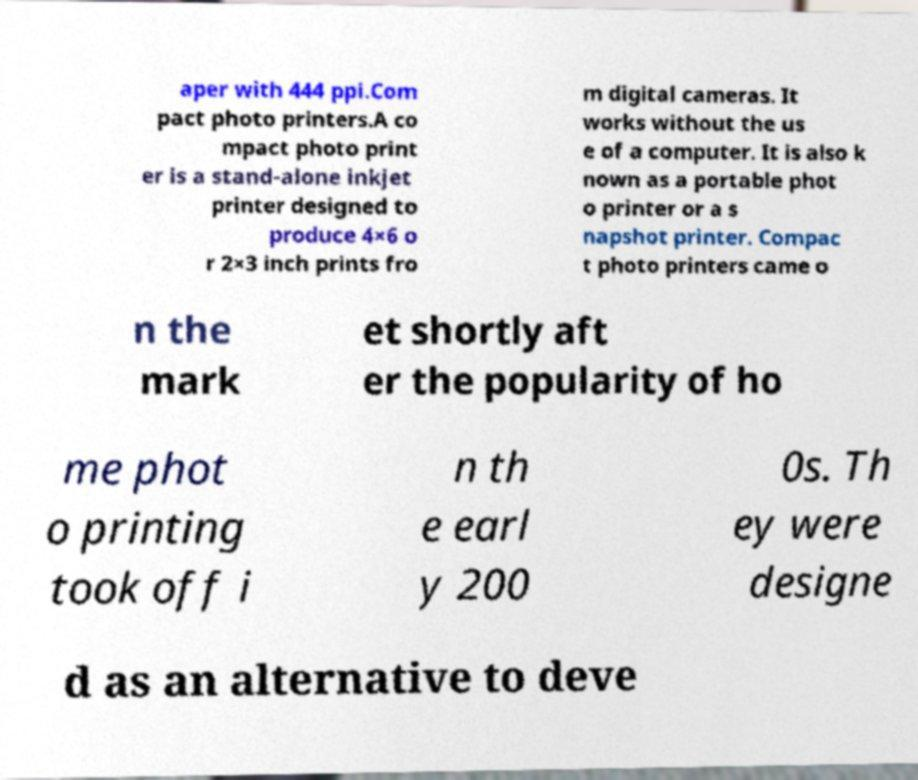Could you assist in decoding the text presented in this image and type it out clearly? aper with 444 ppi.Com pact photo printers.A co mpact photo print er is a stand-alone inkjet printer designed to produce 4×6 o r 2×3 inch prints fro m digital cameras. It works without the us e of a computer. It is also k nown as a portable phot o printer or a s napshot printer. Compac t photo printers came o n the mark et shortly aft er the popularity of ho me phot o printing took off i n th e earl y 200 0s. Th ey were designe d as an alternative to deve 